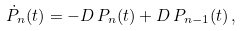Convert formula to latex. <formula><loc_0><loc_0><loc_500><loc_500>\dot { P } _ { n } ( t ) = - D \, P _ { n } ( t ) + D \, P _ { n - 1 } ( t ) \, ,</formula> 